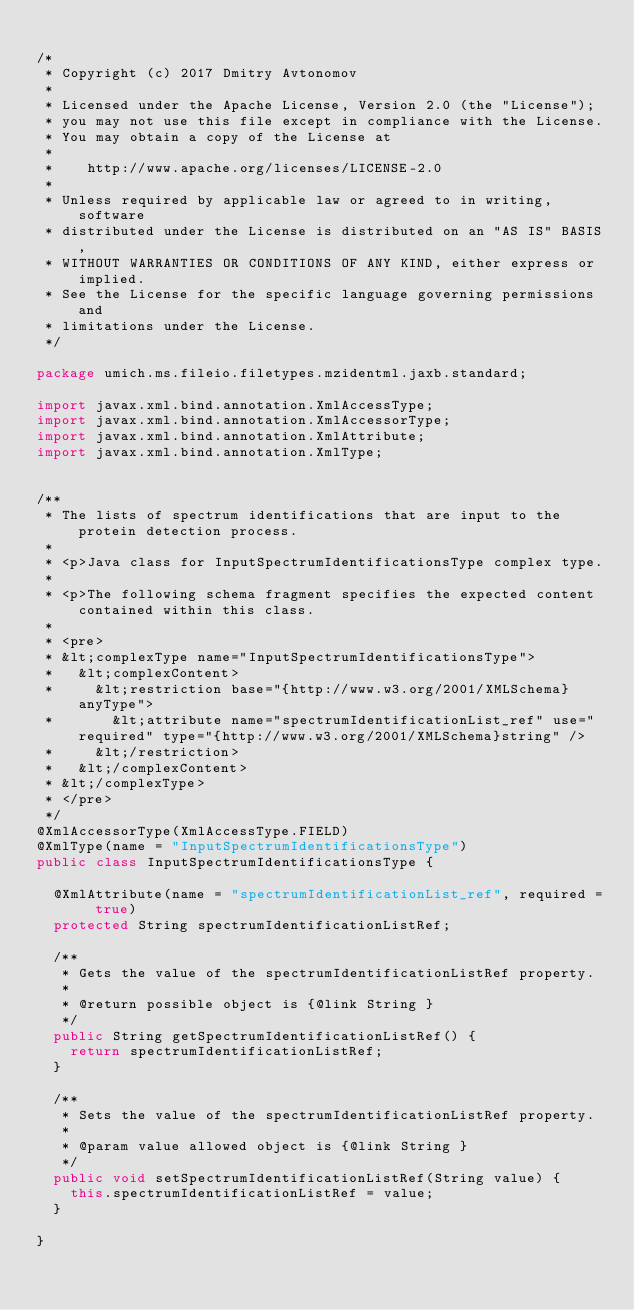<code> <loc_0><loc_0><loc_500><loc_500><_Java_>
/*
 * Copyright (c) 2017 Dmitry Avtonomov
 *
 * Licensed under the Apache License, Version 2.0 (the "License");
 * you may not use this file except in compliance with the License.
 * You may obtain a copy of the License at
 *
 *    http://www.apache.org/licenses/LICENSE-2.0
 *
 * Unless required by applicable law or agreed to in writing, software
 * distributed under the License is distributed on an "AS IS" BASIS,
 * WITHOUT WARRANTIES OR CONDITIONS OF ANY KIND, either express or implied.
 * See the License for the specific language governing permissions and
 * limitations under the License.
 */

package umich.ms.fileio.filetypes.mzidentml.jaxb.standard;

import javax.xml.bind.annotation.XmlAccessType;
import javax.xml.bind.annotation.XmlAccessorType;
import javax.xml.bind.annotation.XmlAttribute;
import javax.xml.bind.annotation.XmlType;


/**
 * The lists of spectrum identifications that are input to the protein detection process.
 *
 * <p>Java class for InputSpectrumIdentificationsType complex type.
 *
 * <p>The following schema fragment specifies the expected content contained within this class.
 *
 * <pre>
 * &lt;complexType name="InputSpectrumIdentificationsType">
 *   &lt;complexContent>
 *     &lt;restriction base="{http://www.w3.org/2001/XMLSchema}anyType">
 *       &lt;attribute name="spectrumIdentificationList_ref" use="required" type="{http://www.w3.org/2001/XMLSchema}string" />
 *     &lt;/restriction>
 *   &lt;/complexContent>
 * &lt;/complexType>
 * </pre>
 */
@XmlAccessorType(XmlAccessType.FIELD)
@XmlType(name = "InputSpectrumIdentificationsType")
public class InputSpectrumIdentificationsType {

  @XmlAttribute(name = "spectrumIdentificationList_ref", required = true)
  protected String spectrumIdentificationListRef;

  /**
   * Gets the value of the spectrumIdentificationListRef property.
   *
   * @return possible object is {@link String }
   */
  public String getSpectrumIdentificationListRef() {
    return spectrumIdentificationListRef;
  }

  /**
   * Sets the value of the spectrumIdentificationListRef property.
   *
   * @param value allowed object is {@link String }
   */
  public void setSpectrumIdentificationListRef(String value) {
    this.spectrumIdentificationListRef = value;
  }

}
</code> 